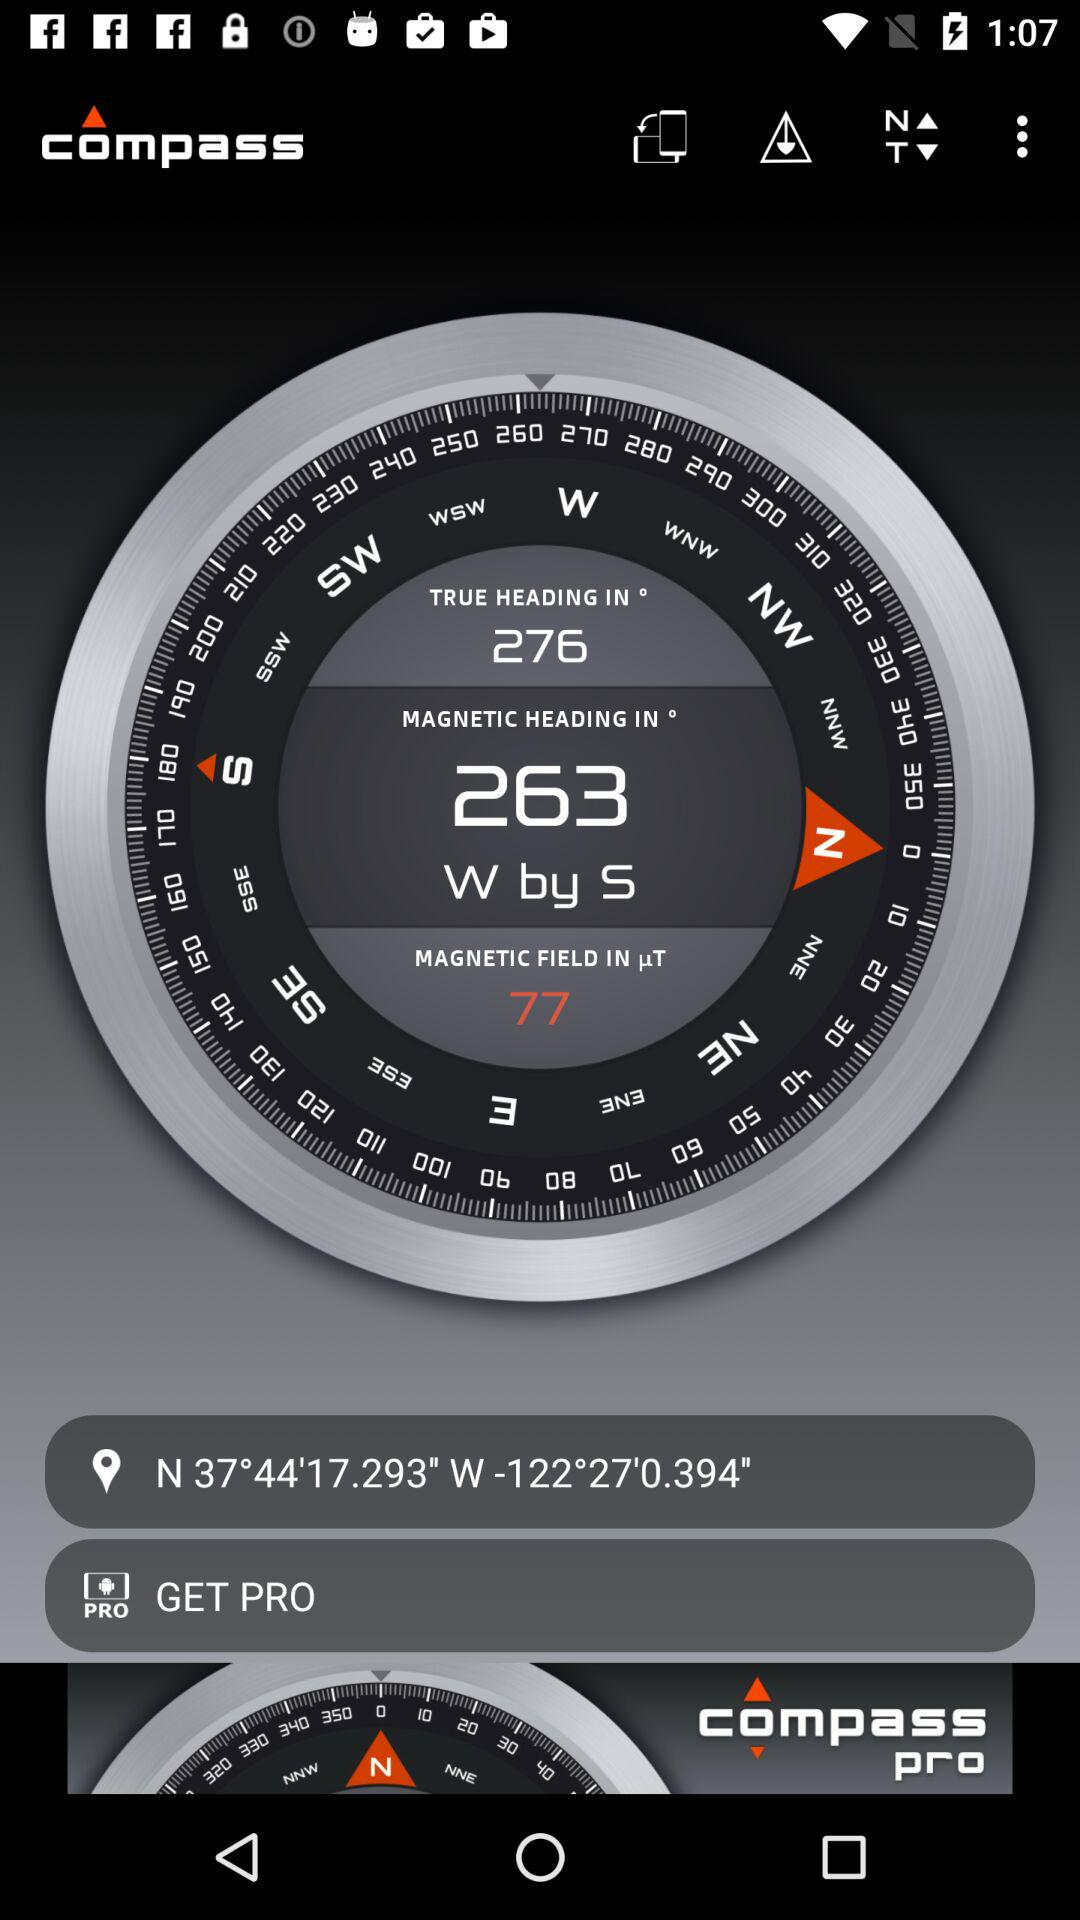What is the application name? The application names are "compass" and "compass pro". 